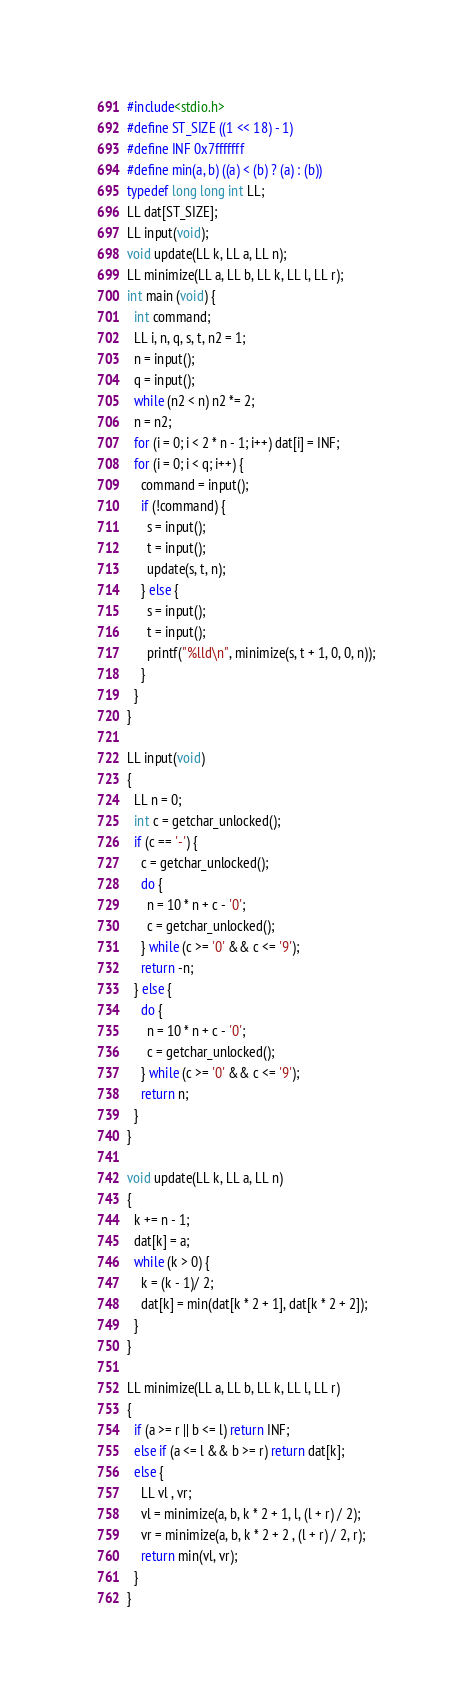<code> <loc_0><loc_0><loc_500><loc_500><_C_>#include<stdio.h>
#define ST_SIZE ((1 << 18) - 1)
#define INF 0x7fffffff
#define min(a, b) ((a) < (b) ? (a) : (b))
typedef long long int LL;
LL dat[ST_SIZE];
LL input(void);
void update(LL k, LL a, LL n);
LL minimize(LL a, LL b, LL k, LL l, LL r);
int main (void) {
  int command;
  LL i, n, q, s, t, n2 = 1;
  n = input();
  q = input();
  while (n2 < n) n2 *= 2;
  n = n2;
  for (i = 0; i < 2 * n - 1; i++) dat[i] = INF;
  for (i = 0; i < q; i++) {
    command = input();
    if (!command) {
      s = input();
      t = input();
      update(s, t, n);
    } else {
      s = input();
      t = input();
      printf("%lld\n", minimize(s, t + 1, 0, 0, n));
    }
  }
}

LL input(void)
{
  LL n = 0;
  int c = getchar_unlocked();
  if (c == '-') {
    c = getchar_unlocked();
    do {
      n = 10 * n + c - '0';
      c = getchar_unlocked();
    } while (c >= '0' && c <= '9');
    return -n;
  } else {
    do {
      n = 10 * n + c - '0';
      c = getchar_unlocked();
    } while (c >= '0' && c <= '9');
    return n;
  }
}

void update(LL k, LL a, LL n)
{
  k += n - 1;
  dat[k] = a;
  while (k > 0) {
    k = (k - 1)/ 2;
    dat[k] = min(dat[k * 2 + 1], dat[k * 2 + 2]);
  }
}

LL minimize(LL a, LL b, LL k, LL l, LL r)
{
  if (a >= r || b <= l) return INF;
  else if (a <= l && b >= r) return dat[k];
  else {
    LL vl , vr;
    vl = minimize(a, b, k * 2 + 1, l, (l + r) / 2);
    vr = minimize(a, b, k * 2 + 2 , (l + r) / 2, r);
    return min(vl, vr);
  }
}
</code> 